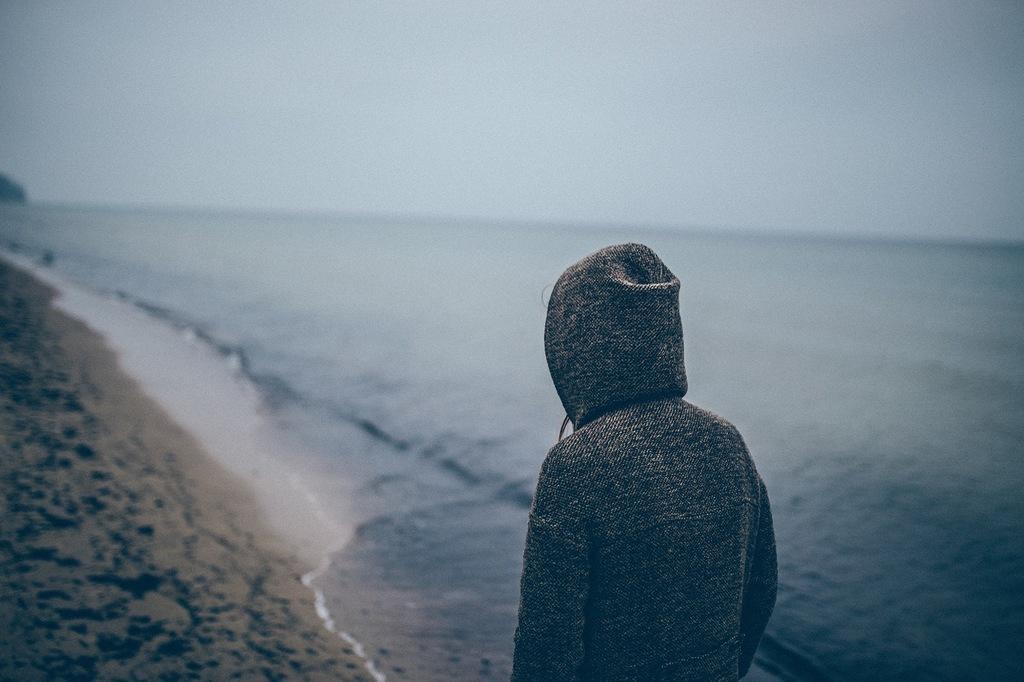Please provide a concise description of this image. In this picture there is a person. At the back it looks like a mountain. At the top there is sky. At the bottom there is sand and water. 